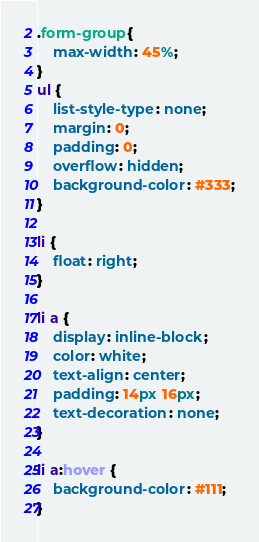<code> <loc_0><loc_0><loc_500><loc_500><_CSS_>.form-group{
	max-width: 45%;
}
ul {
	list-style-type: none;
	margin: 0;
	padding: 0;
	overflow: hidden;
	background-color: #333;
}

li {
	float: right;
}

li a {
	display: inline-block;
	color: white;
	text-align: center;
	padding: 14px 16px;
	text-decoration: none;
}

li a:hover {
	background-color: #111;
}
</code> 